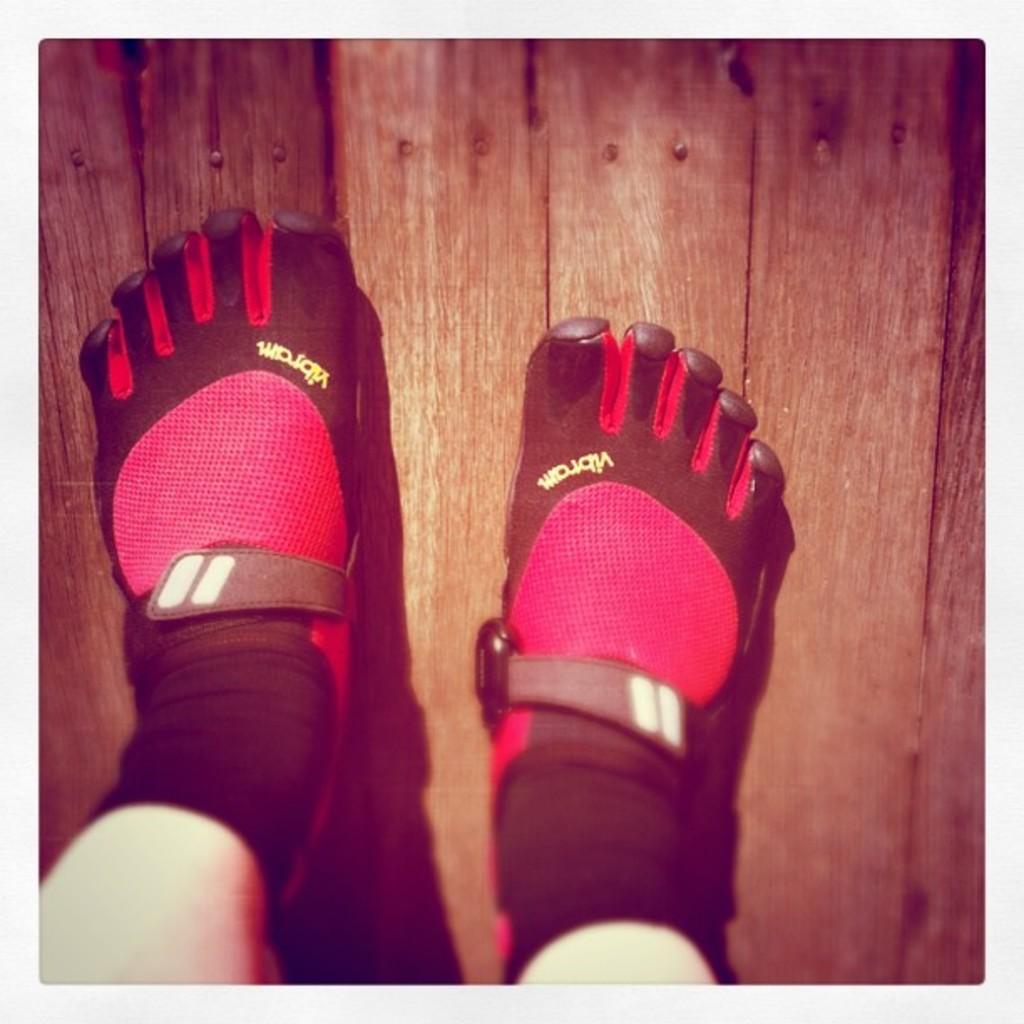Could you give a brief overview of what you see in this image? In this image I can see a person's legs wearing socks and standing on a wooden surface. 